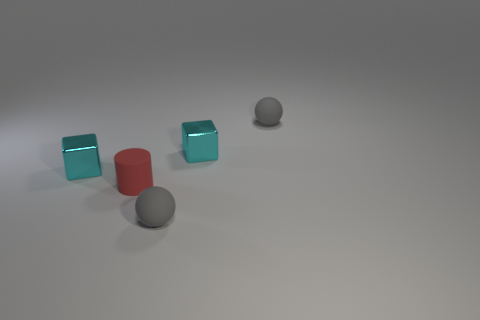There is a gray ball that is in front of the cyan cube that is left of the gray ball in front of the red thing; what is its size?
Your answer should be very brief. Small. How many tiny balls have the same material as the red cylinder?
Ensure brevity in your answer.  2. What is the color of the matte cylinder that is in front of the tiny object that is to the left of the red rubber cylinder?
Keep it short and to the point. Red. How many objects are tiny balls or tiny cyan cubes to the left of the red matte thing?
Your answer should be compact. 3. Is there a small matte sphere of the same color as the tiny matte cylinder?
Provide a succinct answer. No. How many gray things are either tiny balls or small blocks?
Offer a very short reply. 2. What number of other objects are there of the same size as the red thing?
Provide a short and direct response. 4. How many small things are red objects or balls?
Your response must be concise. 3. Do the red cylinder and the matte thing in front of the tiny red cylinder have the same size?
Keep it short and to the point. Yes. What number of other things are there of the same shape as the tiny red thing?
Make the answer very short. 0. 